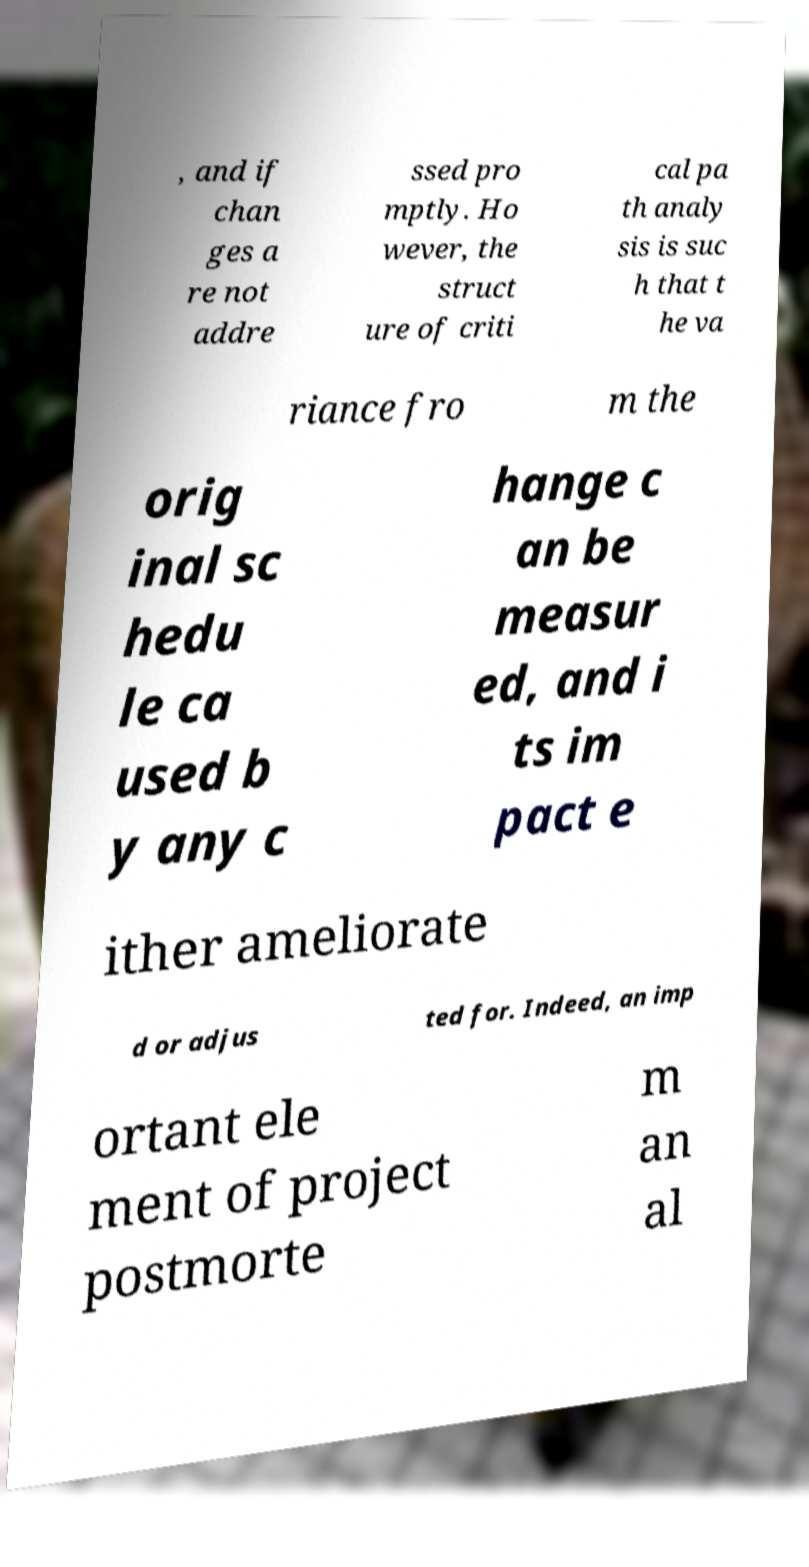Can you read and provide the text displayed in the image?This photo seems to have some interesting text. Can you extract and type it out for me? , and if chan ges a re not addre ssed pro mptly. Ho wever, the struct ure of criti cal pa th analy sis is suc h that t he va riance fro m the orig inal sc hedu le ca used b y any c hange c an be measur ed, and i ts im pact e ither ameliorate d or adjus ted for. Indeed, an imp ortant ele ment of project postmorte m an al 